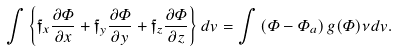<formula> <loc_0><loc_0><loc_500><loc_500>\int \left \{ \mathfrak { f } _ { x } \frac { \partial \varPhi } { \partial x } + \mathfrak { f } _ { y } \frac { \partial \varPhi } { \partial y } + \mathfrak { f } _ { z } \frac { \partial \varPhi } { \partial z } \right \} d v = \int \left ( \varPhi - \varPhi _ { a } \right ) g ( \varPhi ) \nu d v .</formula> 